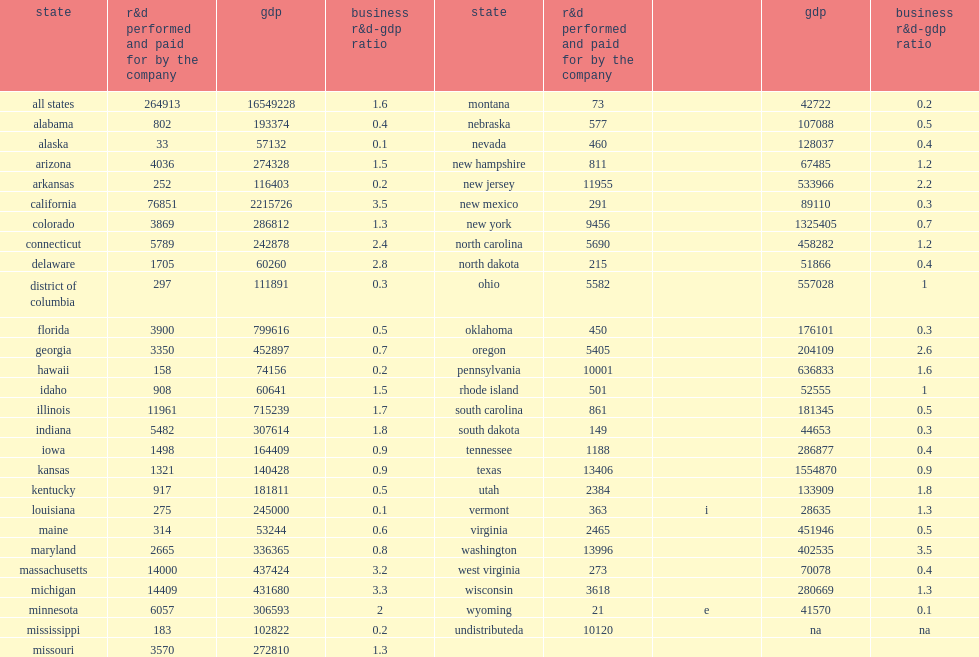How many percent did california alone account of all self-funded business r&d performance in the united states in 2013? 0.290099. How many million dollars did california alone account of all self-funded business r&d performance in the united states in 2013? 76851.0. What was the ratio of business r&d to gdp in 2013? 1.6. 